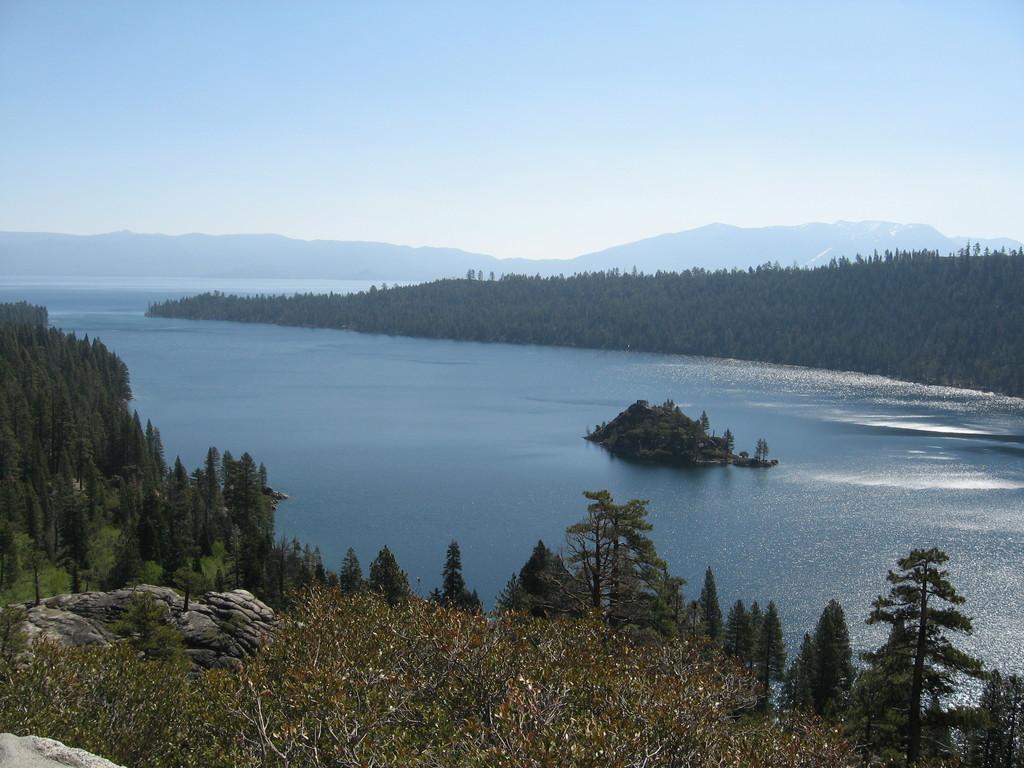How would you summarize this image in a sentence or two? In the foreground we can see trees and rock. In the middle we can see a water body, trees and a rock. At the top there is sky. In the background we can see hills and trees. 